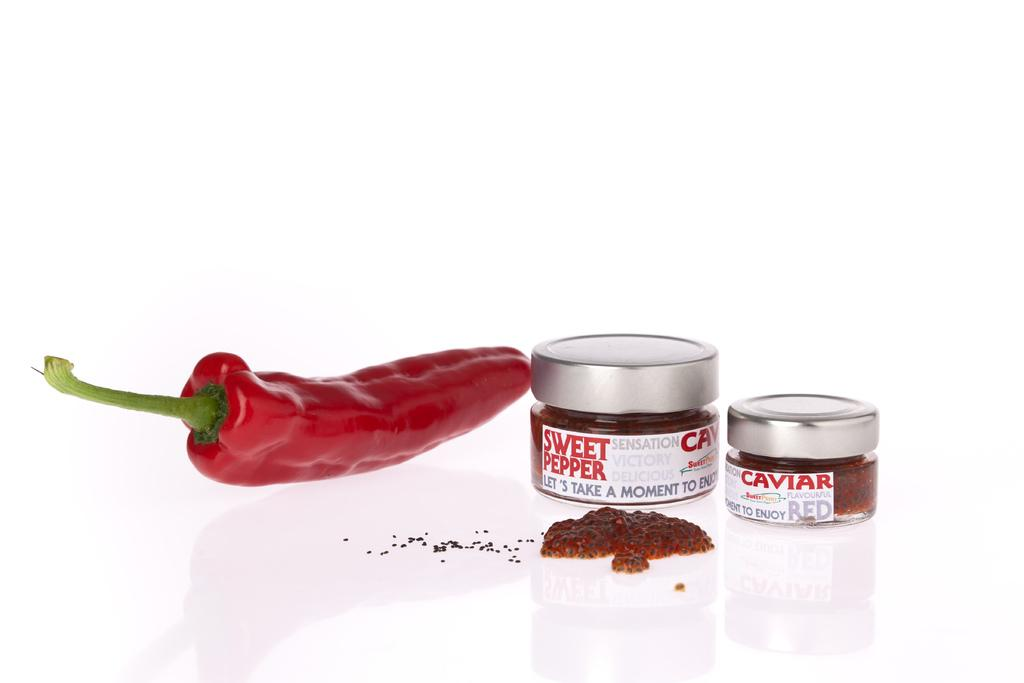What type of objects can be seen in the image? There are food containers in the image. What specific ingredient is present in the image? There is red chili in the image. What disease is being treated with the red chili in the image? There is no indication in the image that the red chili is being used to treat a disease. 